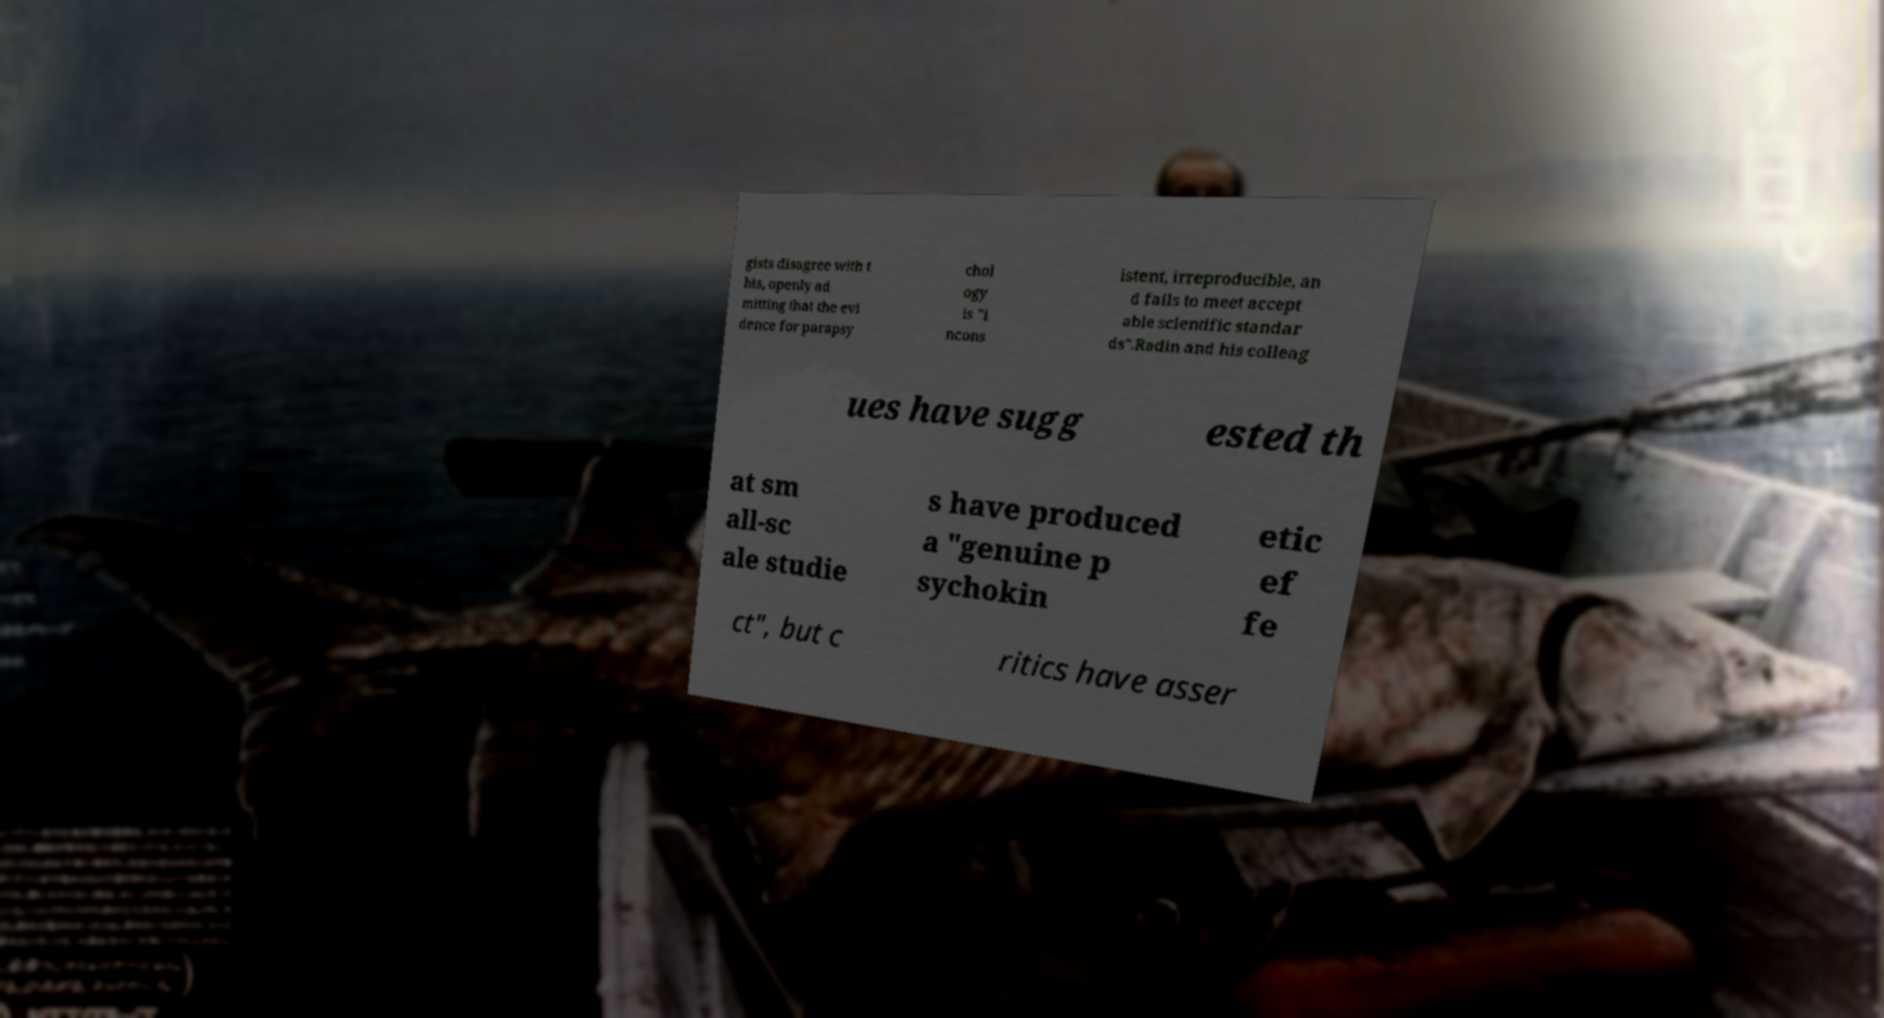Please identify and transcribe the text found in this image. gists disagree with t his, openly ad mitting that the evi dence for parapsy chol ogy is "i ncons istent, irreproducible, an d fails to meet accept able scientific standar ds".Radin and his colleag ues have sugg ested th at sm all-sc ale studie s have produced a "genuine p sychokin etic ef fe ct", but c ritics have asser 